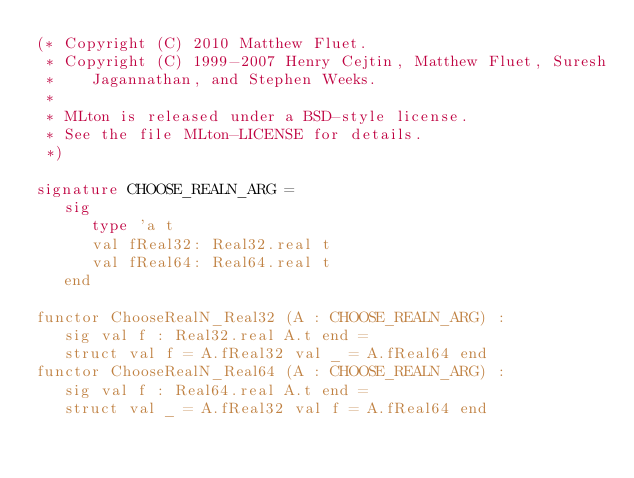Convert code to text. <code><loc_0><loc_0><loc_500><loc_500><_SML_>(* Copyright (C) 2010 Matthew Fluet.
 * Copyright (C) 1999-2007 Henry Cejtin, Matthew Fluet, Suresh
 *    Jagannathan, and Stephen Weeks.
 *
 * MLton is released under a BSD-style license.
 * See the file MLton-LICENSE for details.
 *)

signature CHOOSE_REALN_ARG =
   sig
      type 'a t
      val fReal32: Real32.real t
      val fReal64: Real64.real t
   end

functor ChooseRealN_Real32 (A : CHOOSE_REALN_ARG) : 
   sig val f : Real32.real A.t end = 
   struct val f = A.fReal32 val _ = A.fReal64 end
functor ChooseRealN_Real64 (A : CHOOSE_REALN_ARG) : 
   sig val f : Real64.real A.t end = 
   struct val _ = A.fReal32 val f = A.fReal64 end
</code> 